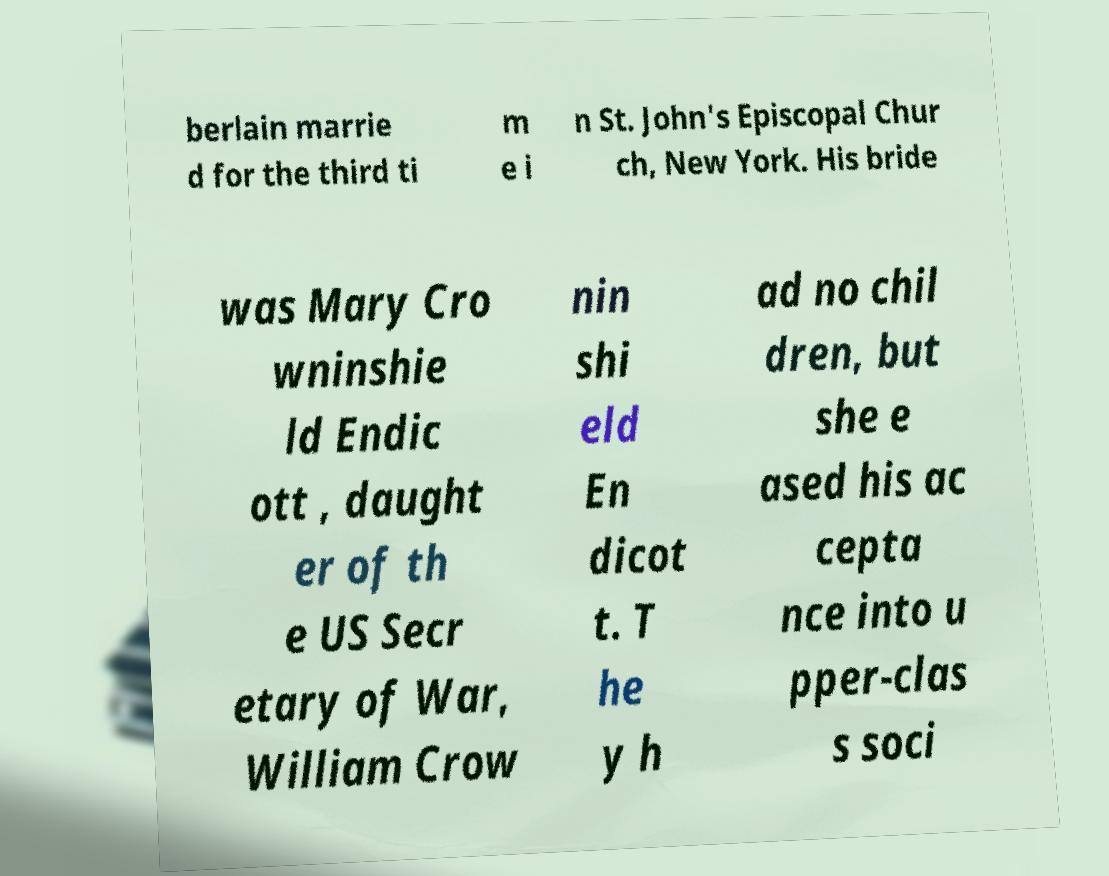Can you accurately transcribe the text from the provided image for me? berlain marrie d for the third ti m e i n St. John's Episcopal Chur ch, New York. His bride was Mary Cro wninshie ld Endic ott , daught er of th e US Secr etary of War, William Crow nin shi eld En dicot t. T he y h ad no chil dren, but she e ased his ac cepta nce into u pper-clas s soci 